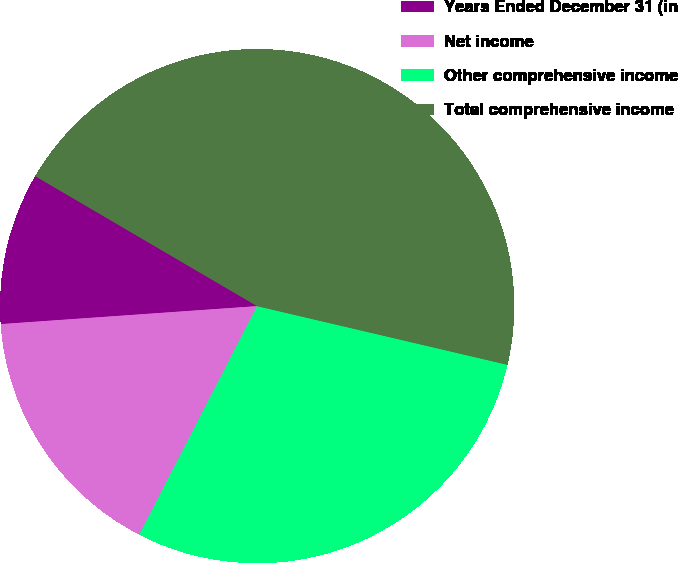<chart> <loc_0><loc_0><loc_500><loc_500><pie_chart><fcel>Years Ended December 31 (in<fcel>Net income<fcel>Other comprehensive income<fcel>Total comprehensive income<nl><fcel>9.55%<fcel>16.31%<fcel>28.91%<fcel>45.23%<nl></chart> 